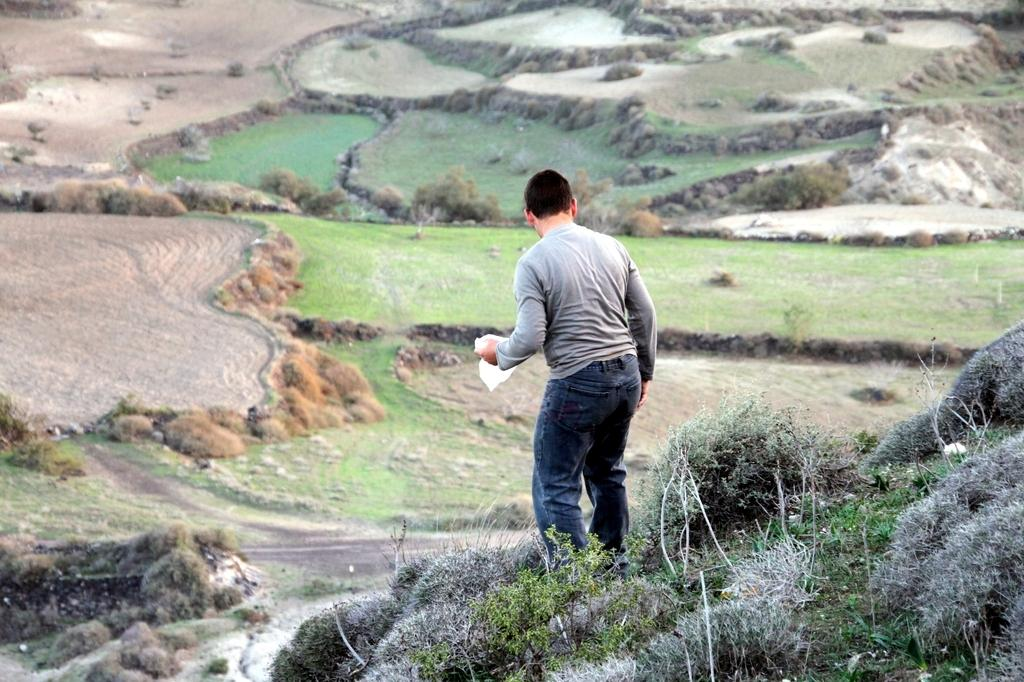What is the main subject of the image? There is a person standing in the image. Where is the person standing? The person is standing on land. What type of vegetation can be seen on the land? There are plants on the land. Can you describe the area in front of the person? There is land with grass in front of the person. What else can be seen on the land with grass? There are plants and rocks present on the land with grass. What color is the knot tied on the person's shoe in the image? There is no knot tied on the person's shoe in the image, and therefore no color can be determined. 